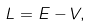<formula> <loc_0><loc_0><loc_500><loc_500>L = E - V ,</formula> 